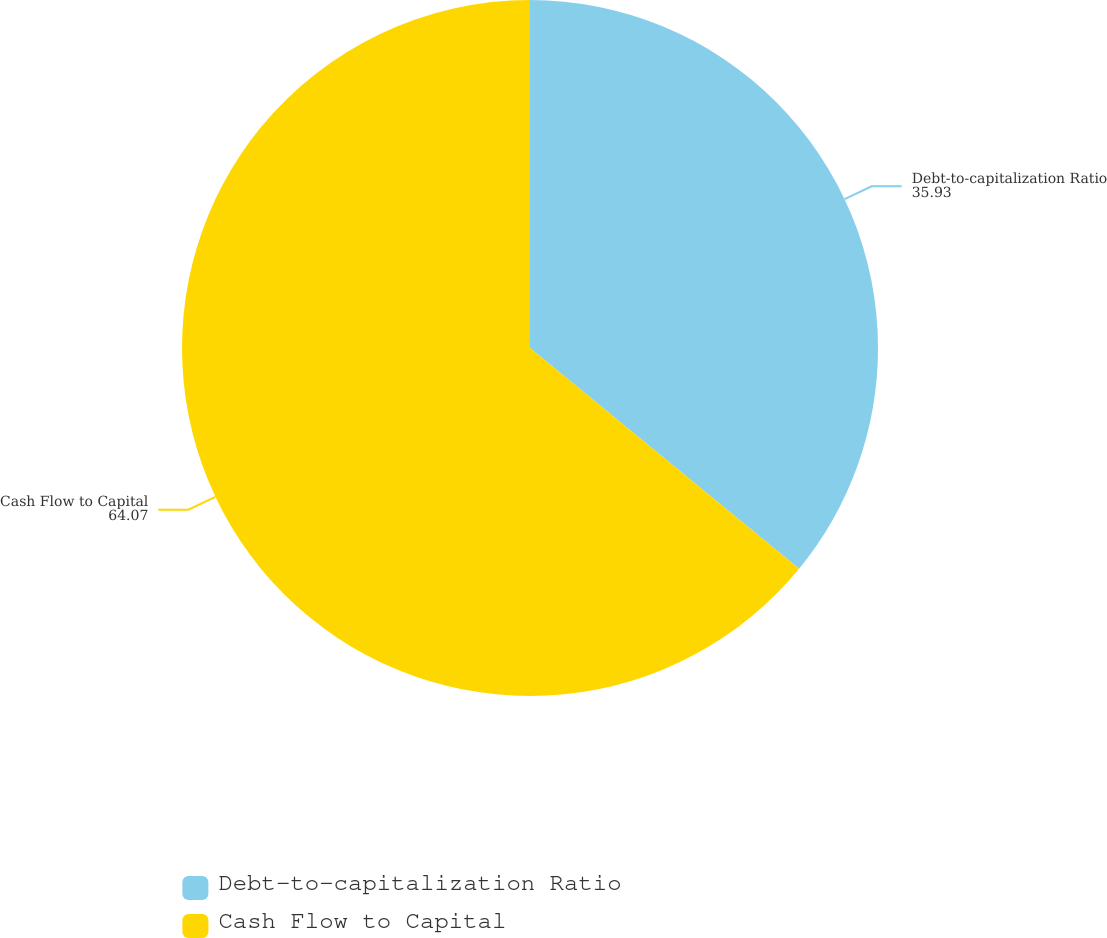Convert chart to OTSL. <chart><loc_0><loc_0><loc_500><loc_500><pie_chart><fcel>Debt-to-capitalization Ratio<fcel>Cash Flow to Capital<nl><fcel>35.93%<fcel>64.07%<nl></chart> 